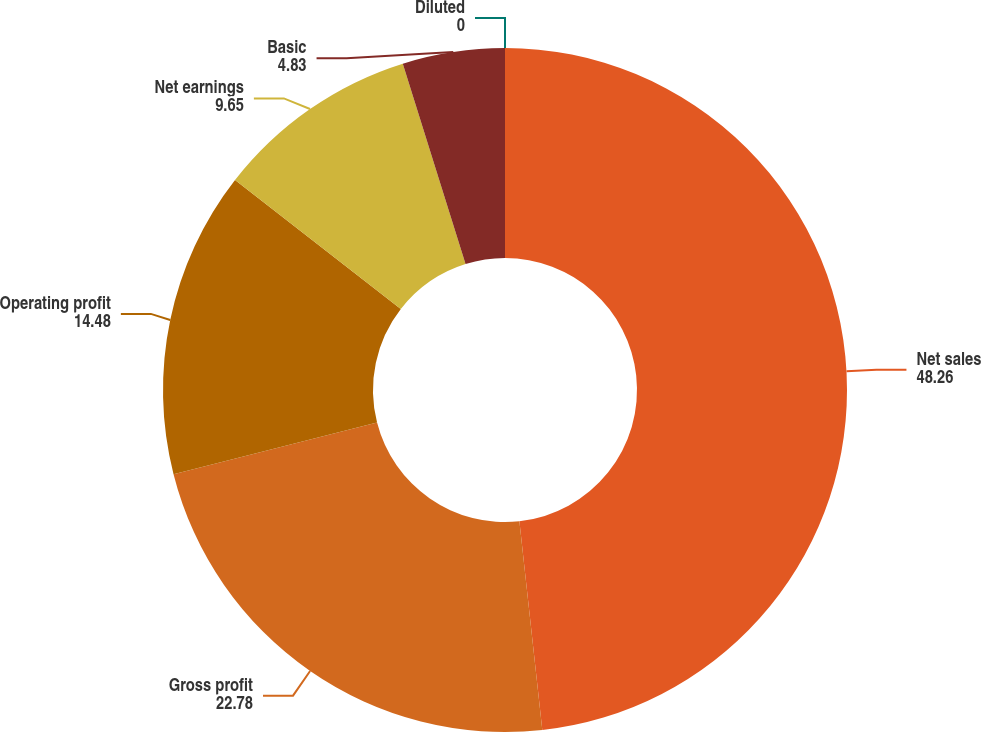Convert chart. <chart><loc_0><loc_0><loc_500><loc_500><pie_chart><fcel>Net sales<fcel>Gross profit<fcel>Operating profit<fcel>Net earnings<fcel>Basic<fcel>Diluted<nl><fcel>48.26%<fcel>22.78%<fcel>14.48%<fcel>9.65%<fcel>4.83%<fcel>0.0%<nl></chart> 